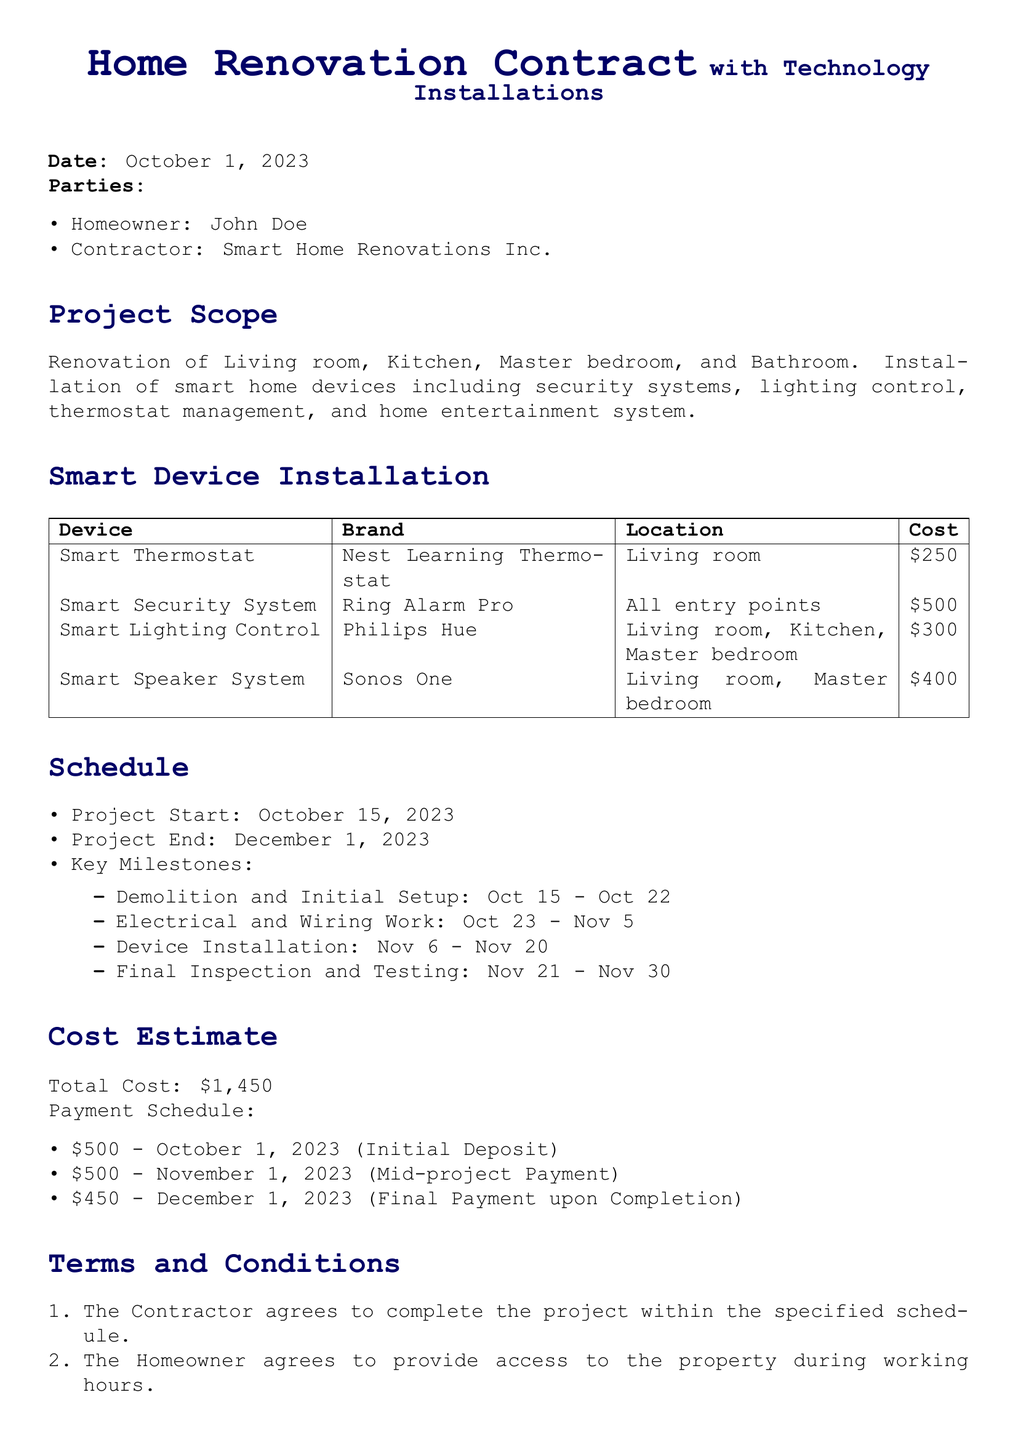What is the date of the contract? The contract date is specified at the beginning of the document as October 1, 2023.
Answer: October 1, 2023 Who is the contractor? The contractor is clearly mentioned in the parties section of the document as Smart Home Renovations Inc.
Answer: Smart Home Renovations Inc What is the total estimated cost? The total estimated cost is summarized in the cost estimate section of the document, which amounts to $1,450.
Answer: $1,450 When does the project start? The project start date is mentioned under the schedule section, which is October 15, 2023.
Answer: October 15, 2023 How much is the initial deposit? The initial deposit amount is specified in the payment schedule section of the document, which is $500.
Answer: $500 What is the warranty period for installed devices? The warranty period is stated in the terms and conditions section, which is one year from the completion date.
Answer: One year Which smart security system is being installed? The smart security system mentioned in the smart device installation table is Ring Alarm Pro.
Answer: Ring Alarm Pro What is the duration for electrical and wiring work? The schedule specifies that the electrical and wiring work will take place from October 23 to November 5, lasting for 14 days.
Answer: October 23 - November 5 How many payment installments are there? The payment schedule includes three installments detailed in the document, indicating there are three payments.
Answer: Three 